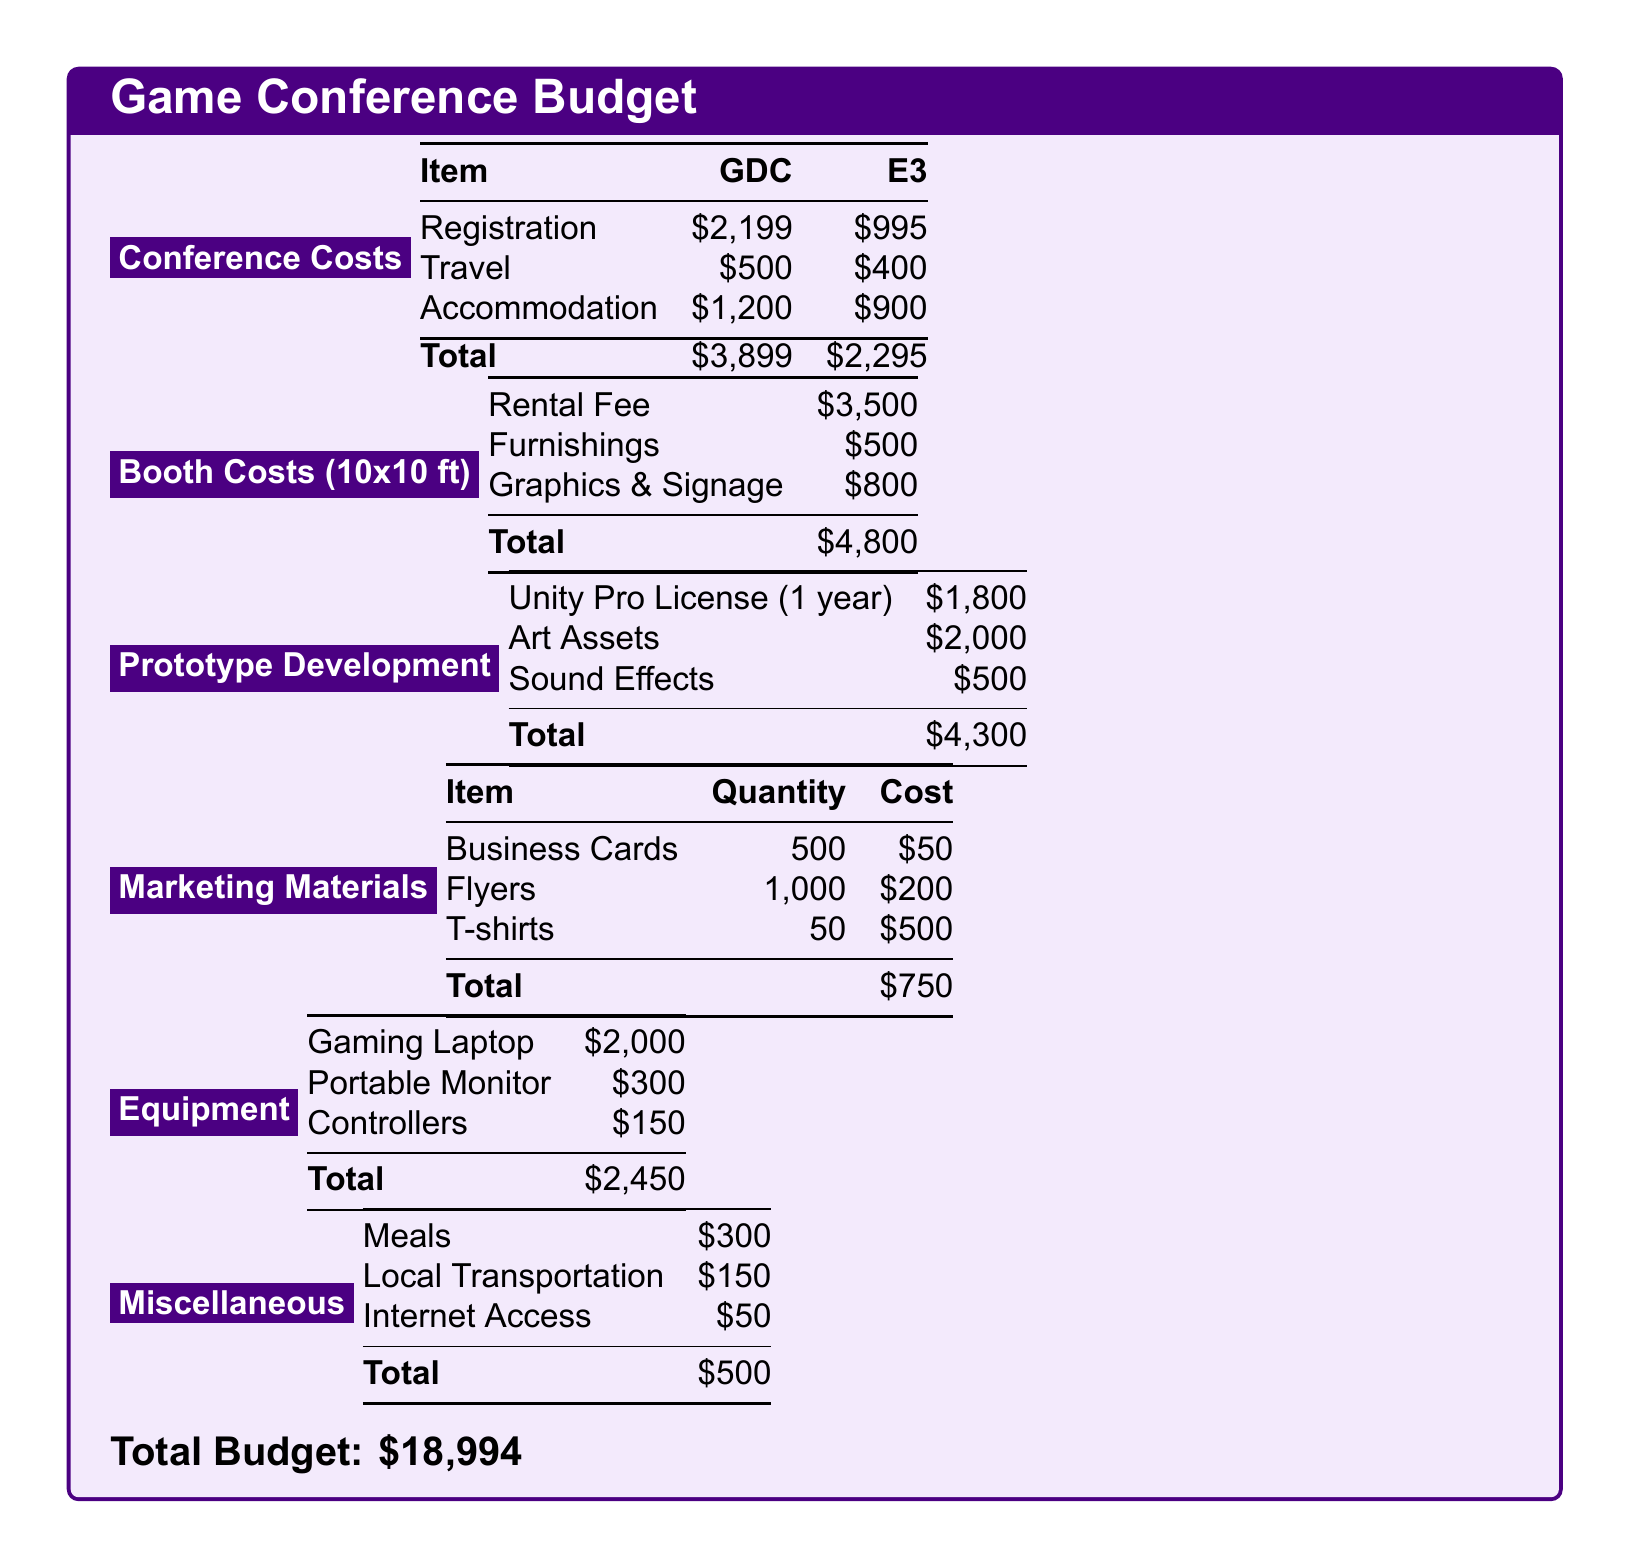What is the registration cost for GDC? The registration cost for GDC is listed under the Conference Costs section of the document.
Answer: $2,199 What is the total cost for E3? The total cost for E3 can be found by adding the individual costs in the Conference Costs section.
Answer: $2,295 How much does a Unity Pro License cost? The cost of the Unity Pro License is shown in the Prototype Development section.
Answer: $1,800 What is the total for booth costs? The total for booth costs is the sum of the rental fee, furnishings, and graphics & signage.
Answer: $4,800 What is the cost of art assets? The cost of art assets is stated in the Prototype Development section of the document.
Answer: $2,000 What is the total budget amount? The total budget amount is stated at the end of the Budget document as the sum of all listed costs.
Answer: $18,994 How many business cards are included in marketing materials? The quantity of business cards can be found in the Marketing Materials section.
Answer: 500 What is the cost of meals under miscellaneous? The cost of meals is one of the entries listed in the Miscellaneous section.
Answer: $300 What is the total cost for equipment? The total cost for equipment is the sum of the listed items in the Equipment section.
Answer: $2,450 